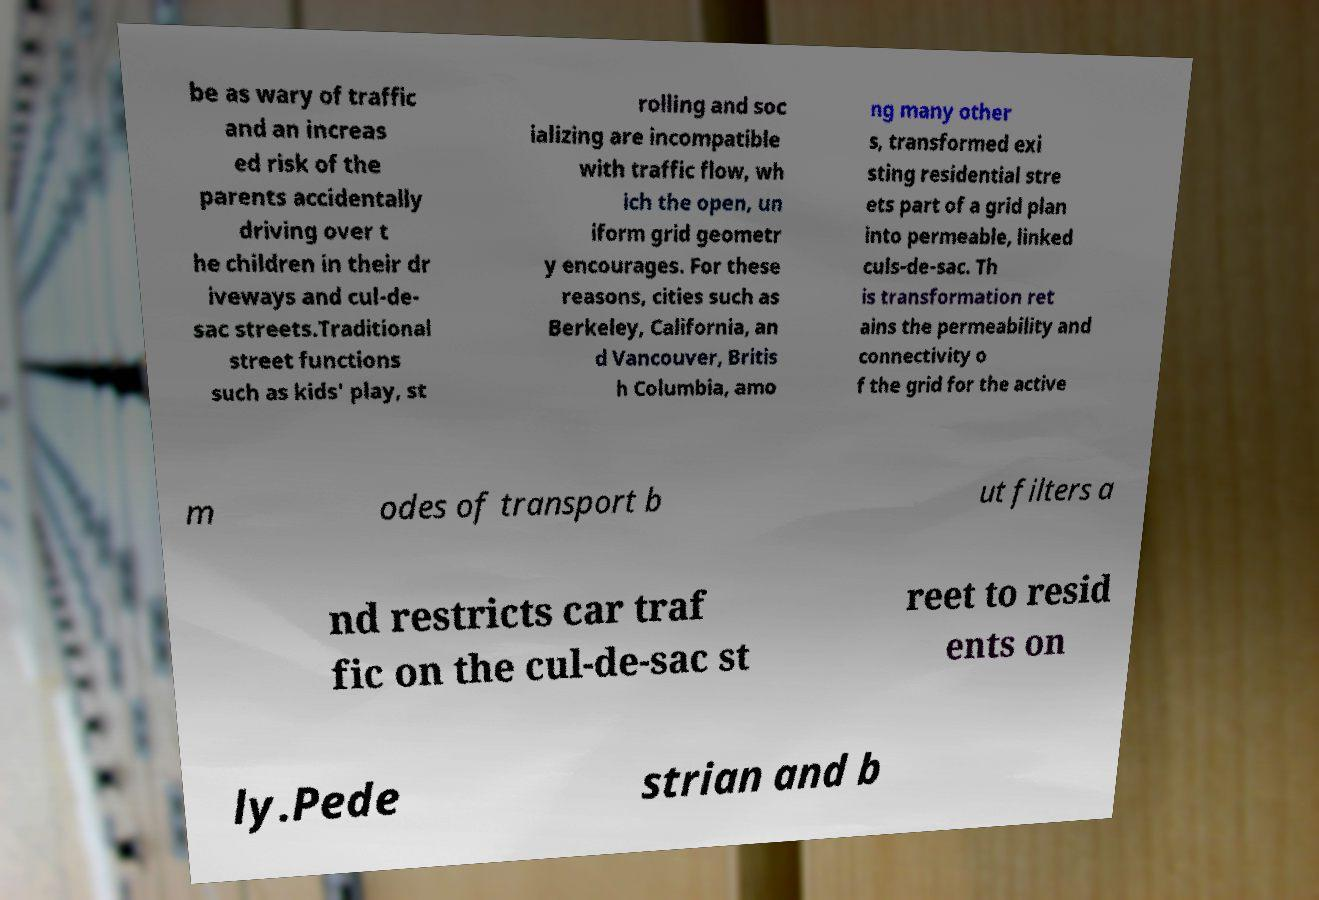Could you extract and type out the text from this image? be as wary of traffic and an increas ed risk of the parents accidentally driving over t he children in their dr iveways and cul-de- sac streets.Traditional street functions such as kids' play, st rolling and soc ializing are incompatible with traffic flow, wh ich the open, un iform grid geometr y encourages. For these reasons, cities such as Berkeley, California, an d Vancouver, Britis h Columbia, amo ng many other s, transformed exi sting residential stre ets part of a grid plan into permeable, linked culs-de-sac. Th is transformation ret ains the permeability and connectivity o f the grid for the active m odes of transport b ut filters a nd restricts car traf fic on the cul-de-sac st reet to resid ents on ly.Pede strian and b 